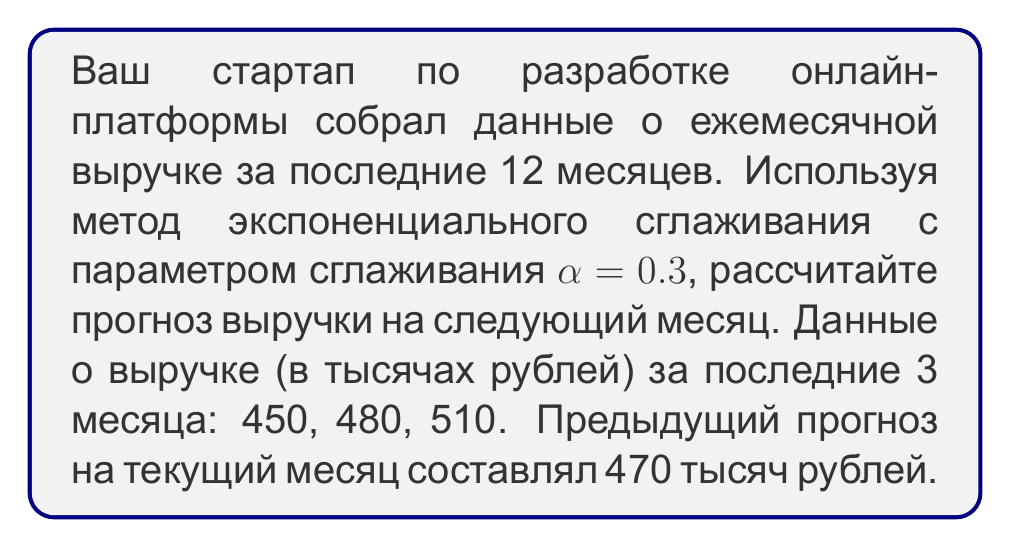Solve this math problem. Для решения этой задачи мы используем формулу экспоненциального сглаживания:

$$F_{t+1} = \alpha Y_t + (1-\alpha)F_t$$

где:
$F_{t+1}$ - прогноз на следующий период
$\alpha$ - параметр сглаживания
$Y_t$ - фактическое значение в текущем периоде
$F_t$ - предыдущий прогноз на текущий период

Шаги решения:

1) Используем данные последнего месяца:
   $Y_t = 510$ (фактическая выручка)
   $F_t = 470$ (предыдущий прогноз)
   $\alpha = 0.3$

2) Подставляем значения в формулу:

   $$F_{t+1} = 0.3 \times 510 + (1-0.3) \times 470$$

3) Вычисляем:
   $$F_{t+1} = 153 + 329 = 482$$

Таким образом, прогноз выручки на следующий месяц составляет 482 тысячи рублей.
Answer: 482 тысячи рублей 